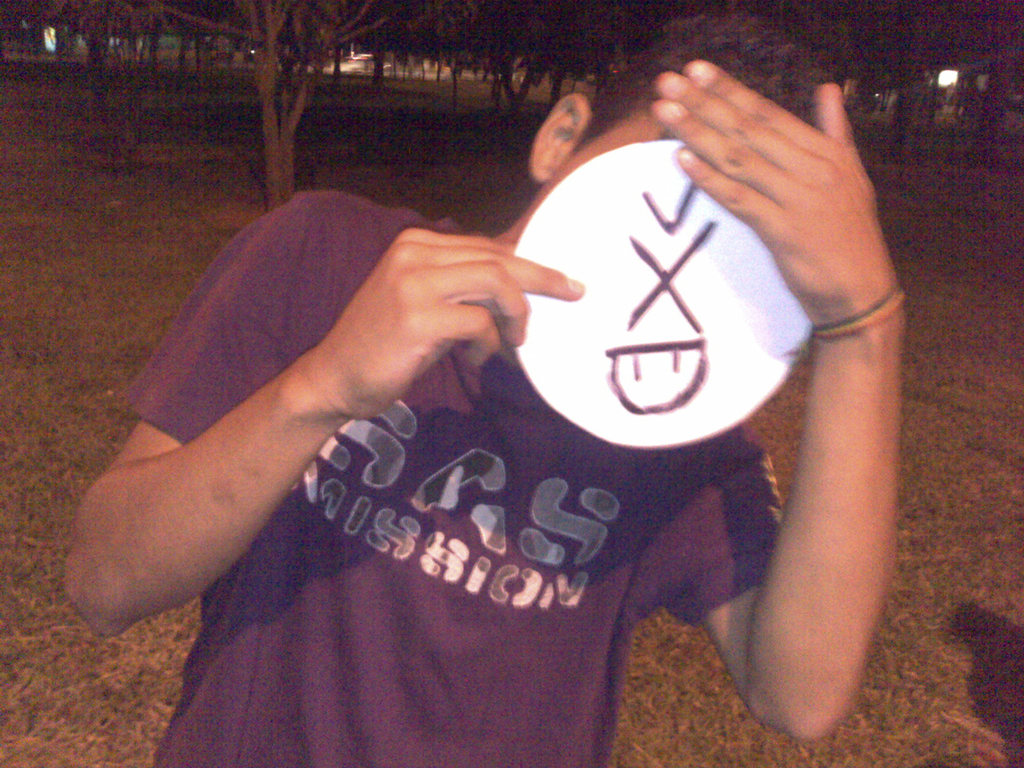Describe the setting in which the photo was taken. The image is taken outdoors at night, indicated by the darkness and ambient lighting in the background, likely in a casual, social setting such as a park or campus area. 